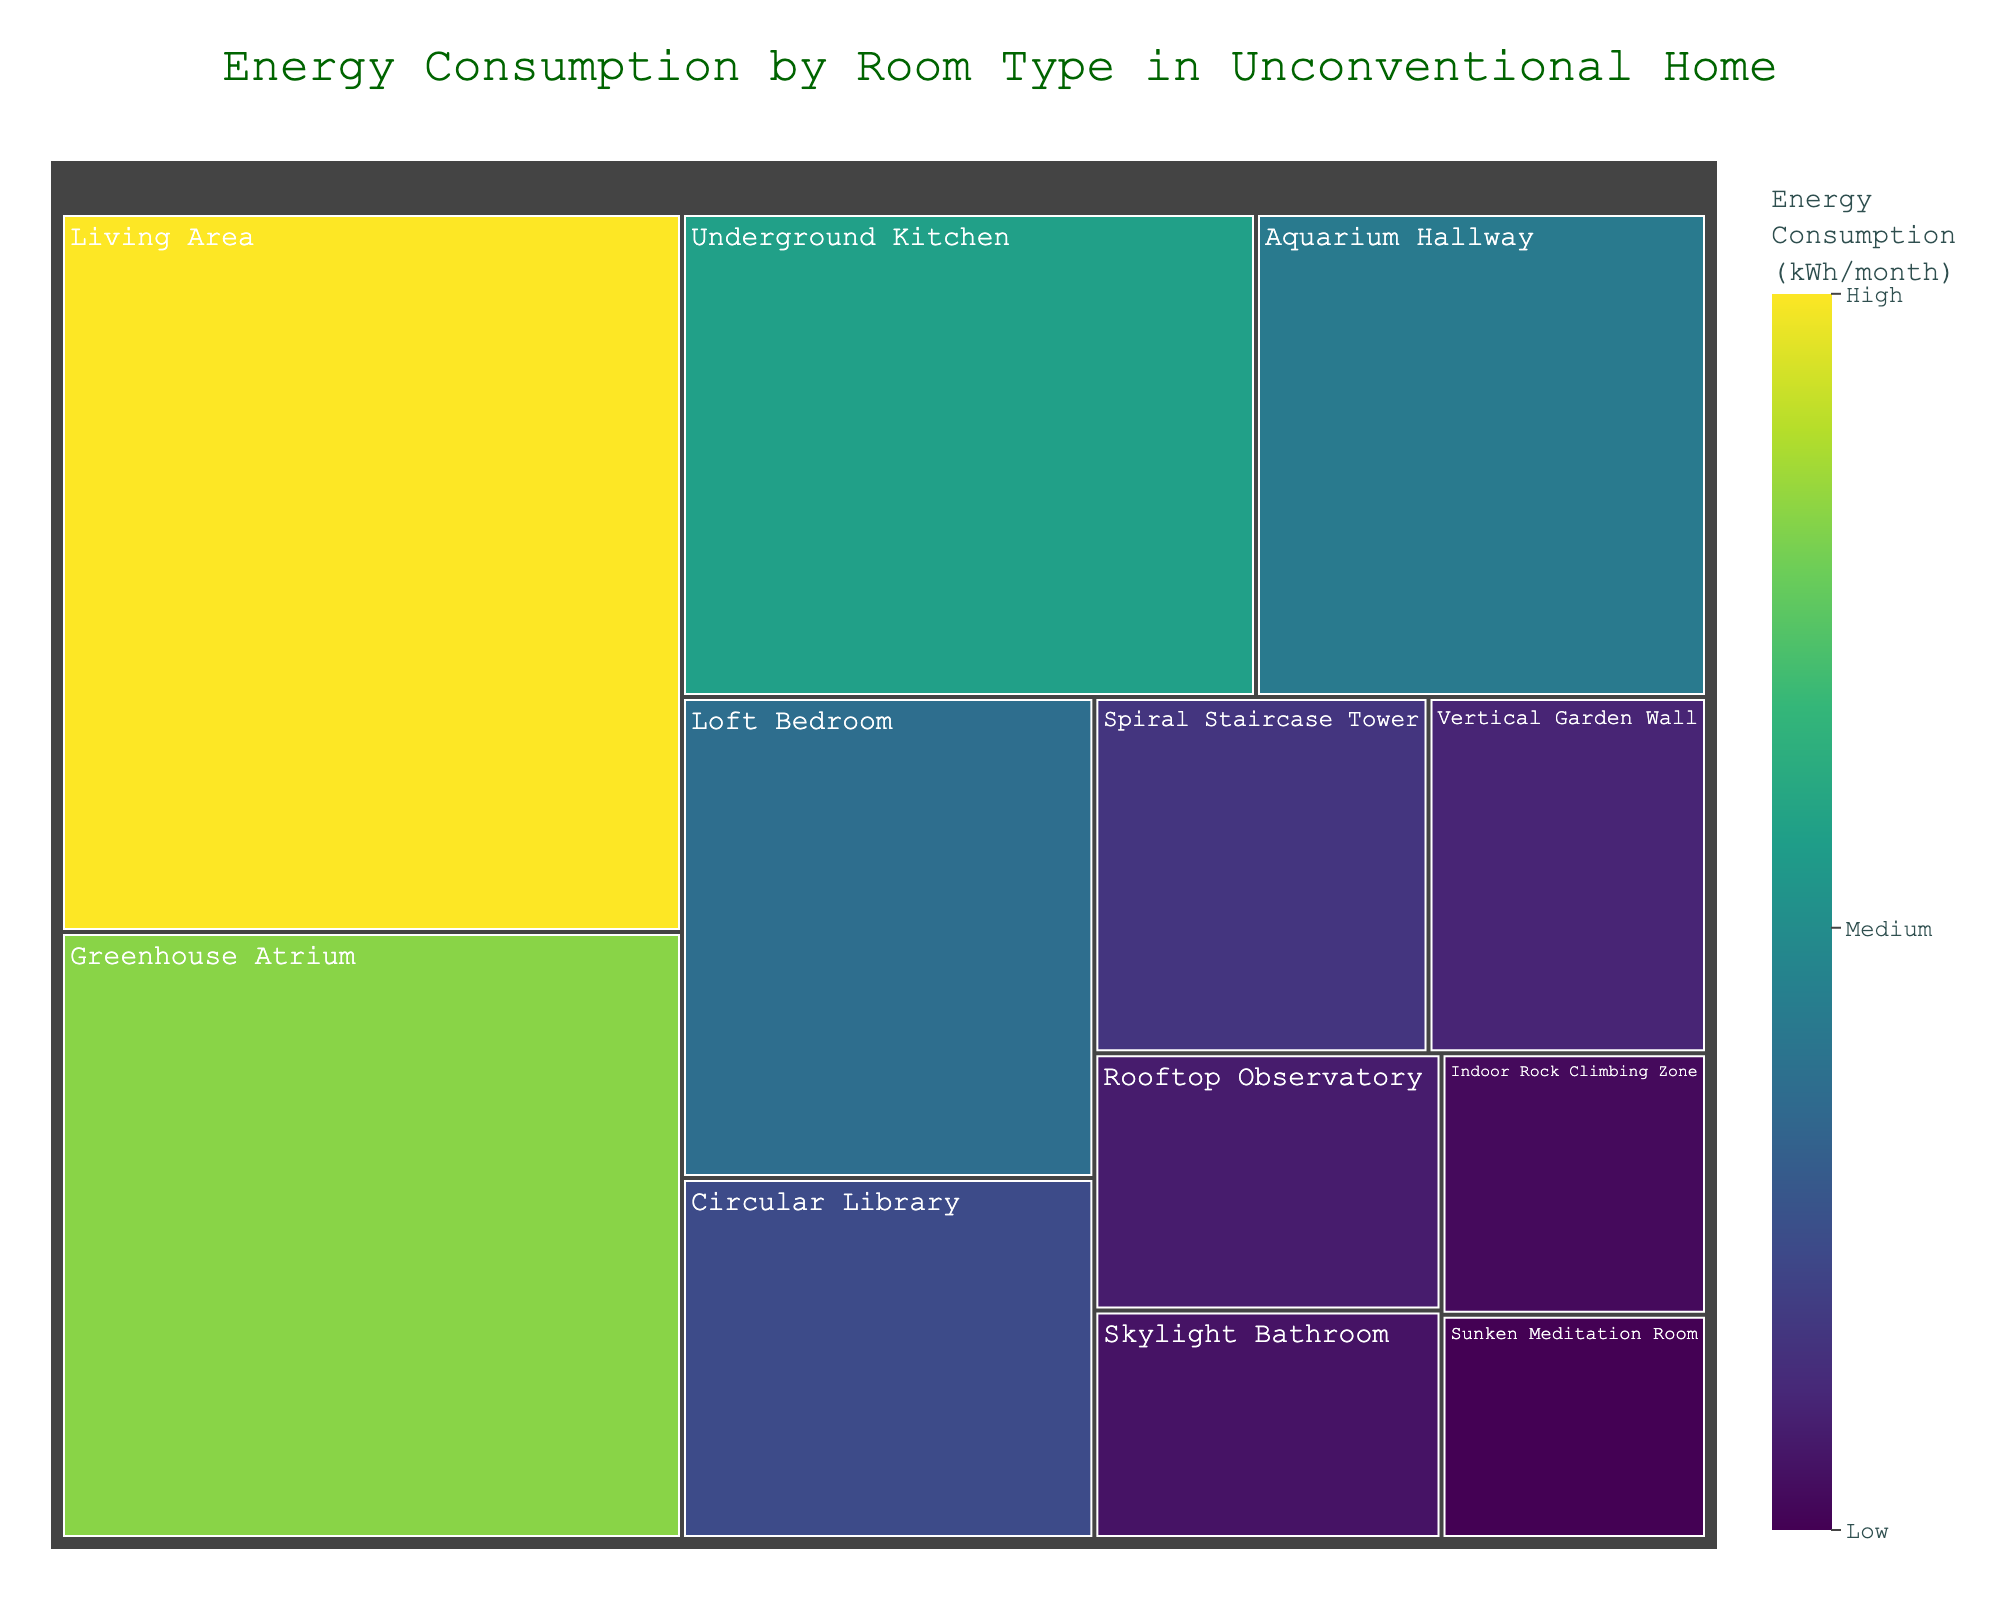What's the title of the treemap? The title is displayed prominently at the top of the figure, it provides a general idea about the content of the chart.
Answer: Energy Consumption by Room Type in Unconventional Home How many different room types are represented in the treemap? By counting the number of unique segments or tiles in the treemap, we can see each represents a different room type.
Answer: 12 Which room type has the highest energy consumption? By observing the size and the color scale of the segments, the largest and the darkest segments indicate the highest energy consumption.
Answer: Living Area Which room type has the lowest energy consumption? Look for the smallest and lightest-colored segment which indicates the lowest energy consumption.
Answer: Sunken Meditation Room What is the energy consumption of the Underground Kitchen? Find the segment labeled "Underground Kitchen" and refer to the value displayed either on the segment or in the hover data.
Answer: 280 kWh/month What is the total energy consumption of the Living Area, Greenhouse Atrium, and Loft Bedroom combined? Sum up the energy values for Living Area, Greenhouse Atrium, and Loft Bedroom: 450 + 380 + 200.
Answer: 1030 kWh/month Which room type uses more energy: the Aquarium Hallway or the Circular Library? Compare the energy consumption values for Aquarium Hallway and Circular Library.
Answer: Aquarium Hallway Is the energy consumption of the Skylight Bathroom higher or lower than that of the Vertical Garden Wall? Compare the energy values of the Skylight Bathroom and the Vertical Garden Wall to determine which one is higher or lower.
Answer: Lower How much more energy does the Living Area consume compared to the Rooftop Observatory? Compute the difference between the energy consumption values of the Living Area and the Rooftop Observatory: 450 - 90.
Answer: 360 kWh/month Which room types have an energy consumption value between 50 and 200 kWh/month? Identify all segments with energy consumption within the range of 50 to 200 kWh/month.
Answer: Spiral Staircase Tower, Loft Bedroom, Circular Library, Vertical Garden Wall, Indoor Rock Climbing Zone, Skylight Bathroom, Sunken Meditation Room 